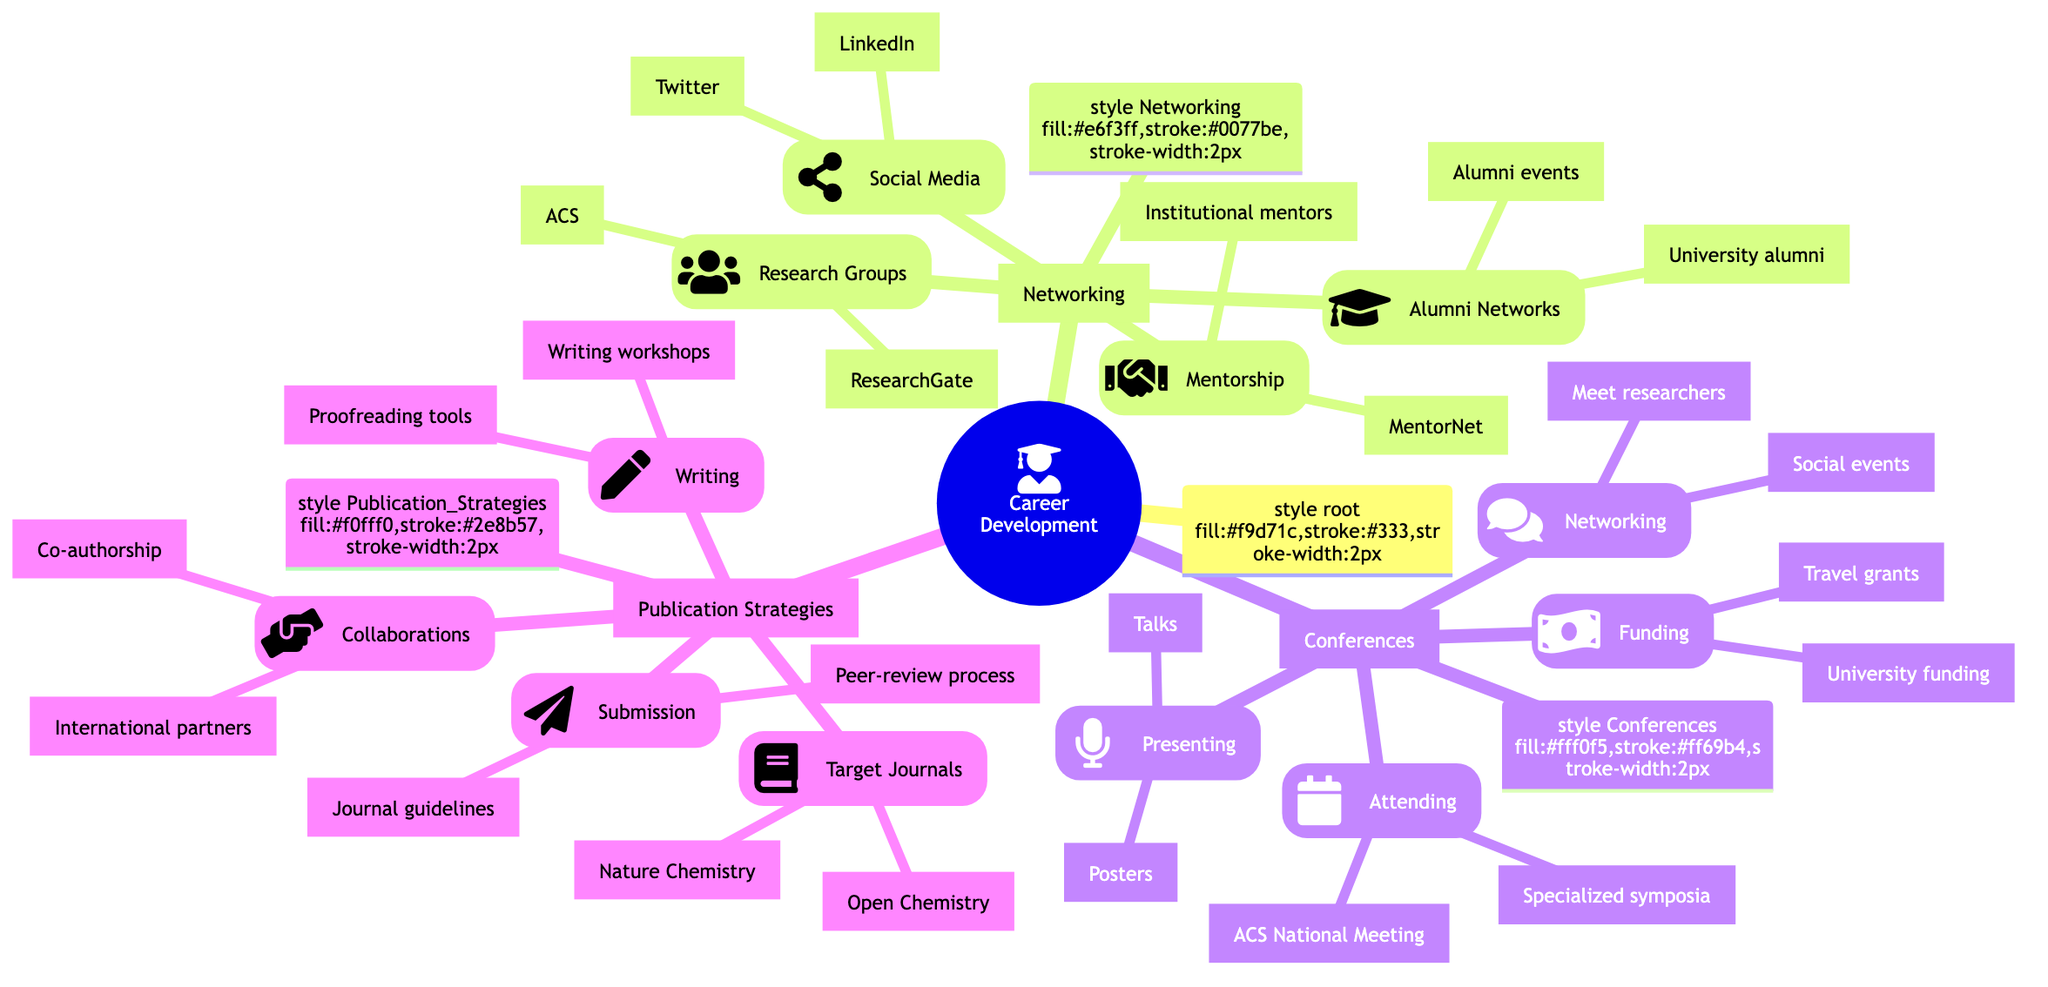What are two examples of research groups to join? The diagram specifies two research groups: the American Chemical Society (ACS) and ResearchGate under the "Research Groups" section of Networking.
Answer: American Chemical Society, ResearchGate How many sections are there under the Career Development category? The top-level category "Career Development" contains three main sections: Networking, Conferences, and Publication Strategies. Therefore, the total number of sections is three.
Answer: 3 What method is suggested for social media networking? In the Social Media section, it suggests creating a LinkedIn profile for professional networking, which is a specific method listed there.
Answer: Create a LinkedIn profile Which funding opportunities can be sought for attending conferences? The "Funding" subsection under Conferences mentions two sources: travel grants from organizations like the Royal Society of Chemistry and university department funding opportunities.
Answer: Travel grants, university funding What is the relationship between the Networking and Conferences sections? Networking and Conferences are both major categories under the Career Development mind map, indicating they are two distinct but interconnected areas that support career advancement.
Answer: Two main areas supporting career advancement What are the two aspects of conference attendance mentioned? The "Attending" section of Conferences lists two specific activities: participating in major conferences like the ACS National Meeting and attending specialized symposia and workshops.
Answer: ACS National Meeting, specialized symposia Which strategy is recommended for improving academic writing? The Writing section under Publication Strategies highlights attending academic writing workshops as a method for enhancing writing skills, providing a direct strategy within the mind map.
Answer: Attend academic writing workshops What types of collaboration are mentioned in the Publication Strategies section? The Collaborations subsection lists two forms of partnerships: co-authorship with other researchers and engaging with international collaborators, identifying the types of collaboration suggested.
Answer: Co-authorship, international collaborators How many different types are there under the Conferences category? The Conferences category contains four distinct types: Attending, Presenting, Networking, and Funding, indicating the various aspects of conference participation.
Answer: 4 